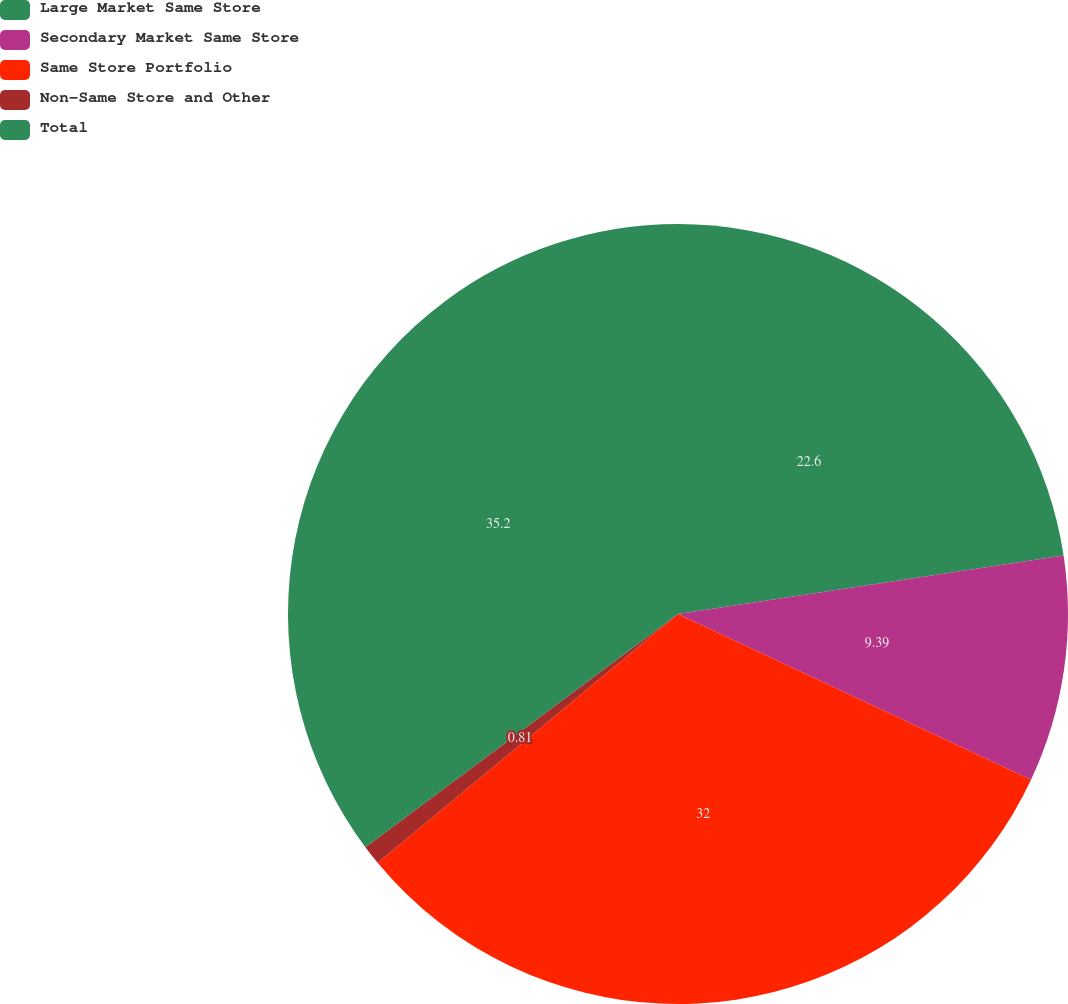Convert chart to OTSL. <chart><loc_0><loc_0><loc_500><loc_500><pie_chart><fcel>Large Market Same Store<fcel>Secondary Market Same Store<fcel>Same Store Portfolio<fcel>Non-Same Store and Other<fcel>Total<nl><fcel>22.6%<fcel>9.39%<fcel>32.0%<fcel>0.81%<fcel>35.2%<nl></chart> 